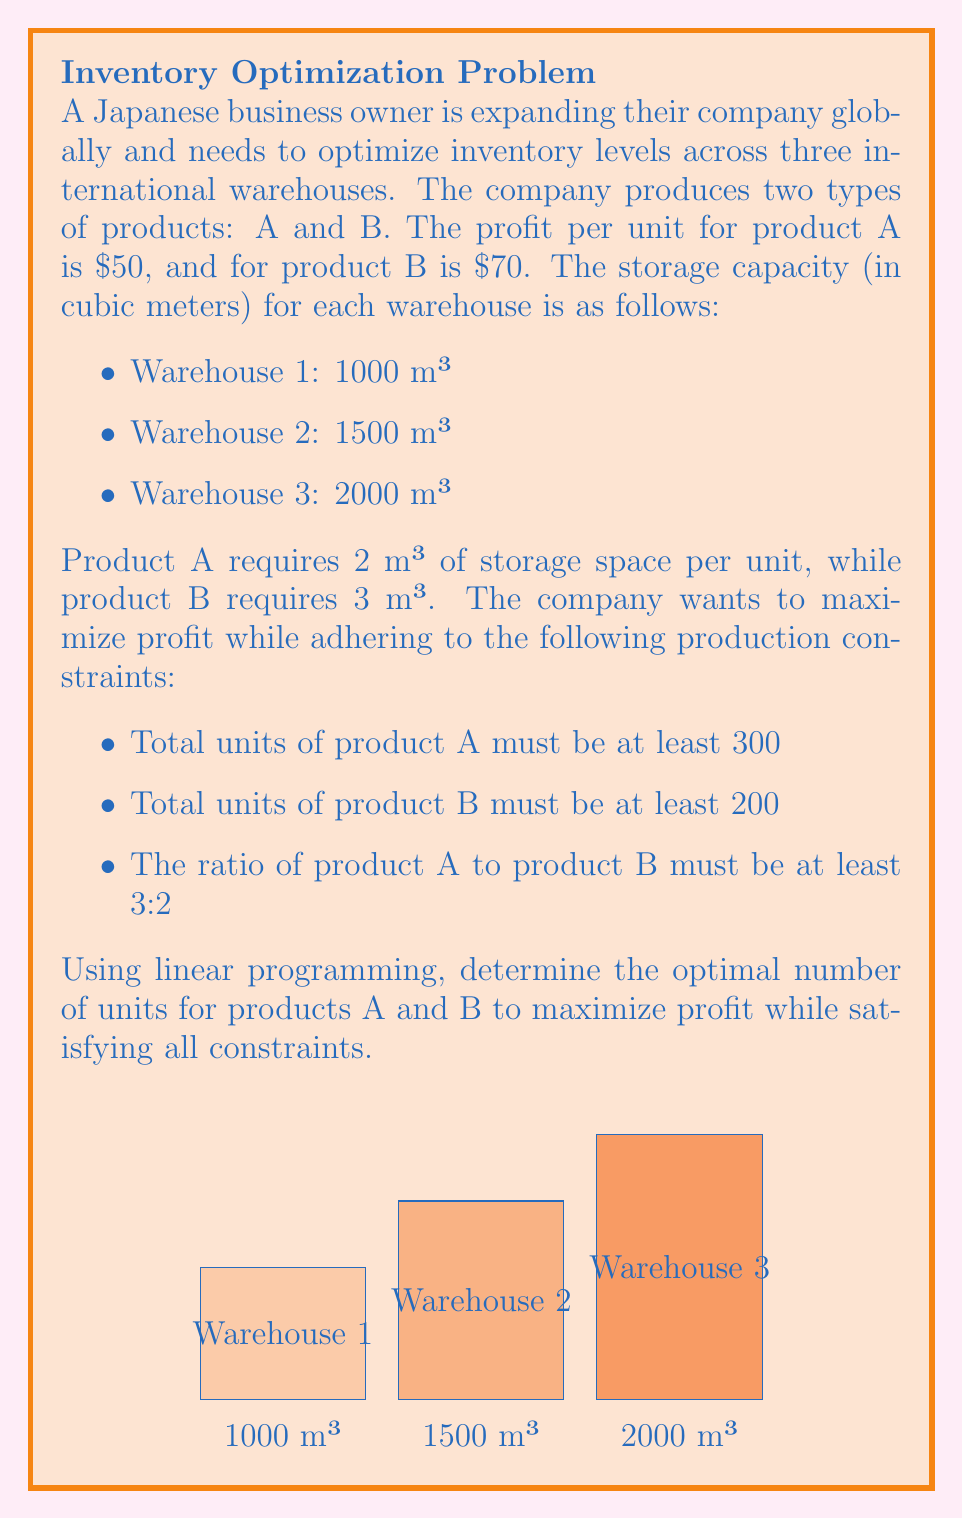Could you help me with this problem? Let's solve this linear programming problem step by step:

1) Define variables:
   $x_A$ = number of units of product A
   $x_B$ = number of units of product B

2) Objective function (maximize profit):
   $\text{Maximize } Z = 50x_A + 70x_B$

3) Constraints:
   a) Storage capacity:
      Warehouse 1: $2x_A + 3x_B \leq 1000$
      Warehouse 2: $2x_A + 3x_B \leq 1500$
      Warehouse 3: $2x_A + 3x_B \leq 2000$
   b) Minimum production:
      $x_A \geq 300$
      $x_B \geq 200$
   c) Ratio constraint:
      $x_A \geq \frac{3}{2}x_B$
   d) Non-negativity:
      $x_A, x_B \geq 0$

4) Simplify constraints:
   - The storage capacity constraint for Warehouse 3 (2000 m³) is the most restrictive, so we can ignore the other two.
   - Combining the ratio and minimum production constraints:
     $x_A \geq \max(300, \frac{3}{2}x_B)$

5) Solve graphically or using software:
   The optimal solution occurs at the intersection of these constraints:
   $2x_A + 3x_B = 2000$ (storage capacity)
   $x_A = \frac{3}{2}x_B$ (ratio constraint)

6) Solving these equations:
   $2(\frac{3}{2}x_B) + 3x_B = 2000$
   $3x_B + 3x_B = 2000$
   $6x_B = 2000$
   $x_B = \frac{2000}{6} \approx 333.33$

   $x_A = \frac{3}{2}x_B = \frac{3}{2} \cdot \frac{2000}{6} = 500$

7) Rounding down to ensure we don't exceed storage capacity:
   $x_A = 500$
   $x_B = 333$

8) Verify constraints:
   Storage: $2(500) + 3(333) = 1999 \leq 2000$
   Minimum production: $500 > 300$, $333 > 200$
   Ratio: $500 > \frac{3}{2}(333)$

9) Calculate maximum profit:
   $Z = 50(500) + 70(333) = 48,310$
Answer: Product A: 500 units, Product B: 333 units, Maximum profit: $48,310 